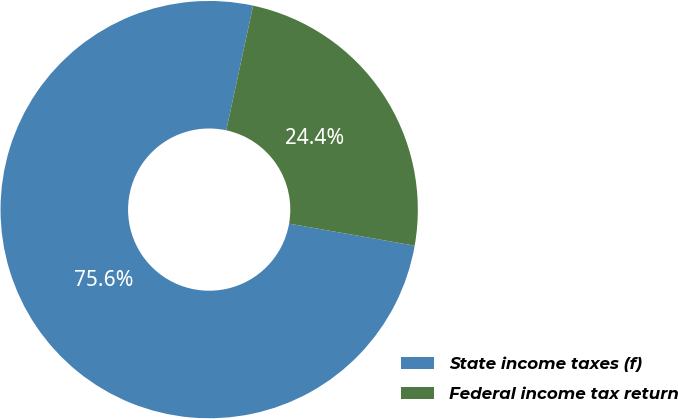Convert chart to OTSL. <chart><loc_0><loc_0><loc_500><loc_500><pie_chart><fcel>State income taxes (f)<fcel>Federal income tax return<nl><fcel>75.61%<fcel>24.39%<nl></chart> 